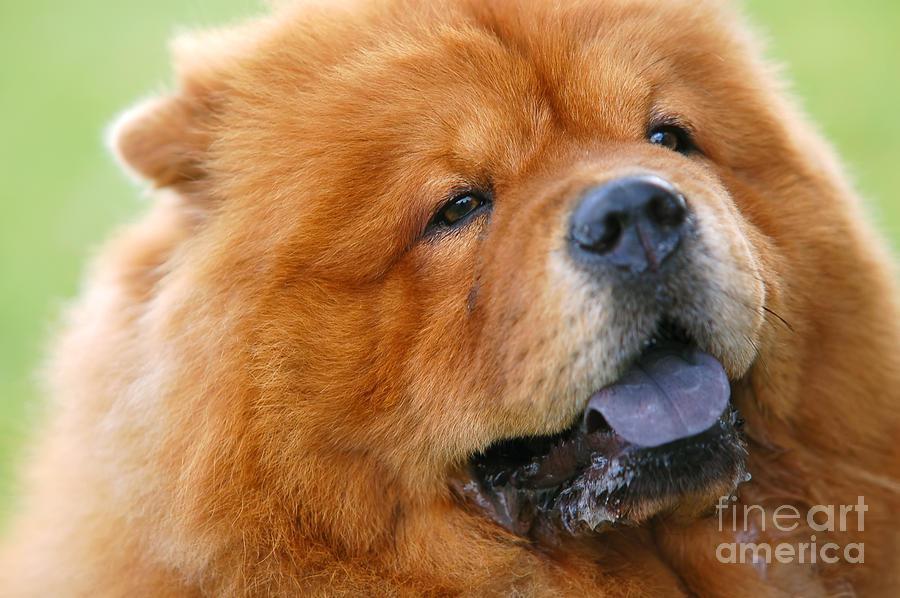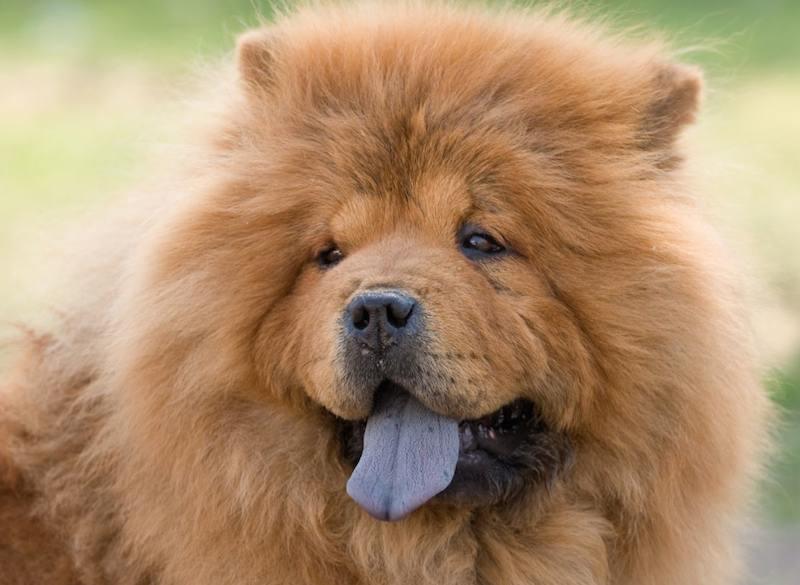The first image is the image on the left, the second image is the image on the right. Assess this claim about the two images: "Two dog tongues are visible". Correct or not? Answer yes or no. Yes. 